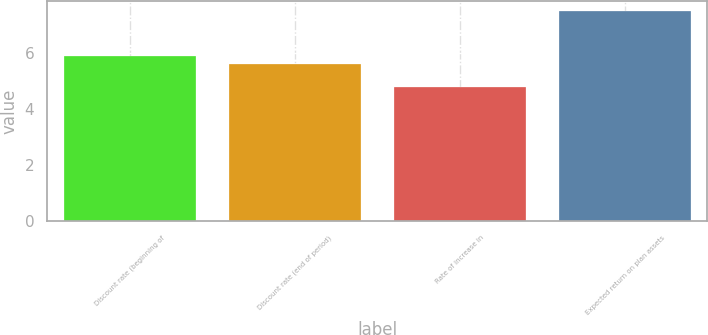Convert chart. <chart><loc_0><loc_0><loc_500><loc_500><bar_chart><fcel>Discount rate (beginning of<fcel>Discount rate (end of period)<fcel>Rate of increase in<fcel>Expected return on plan assets<nl><fcel>5.9<fcel>5.6<fcel>4.8<fcel>7.5<nl></chart> 